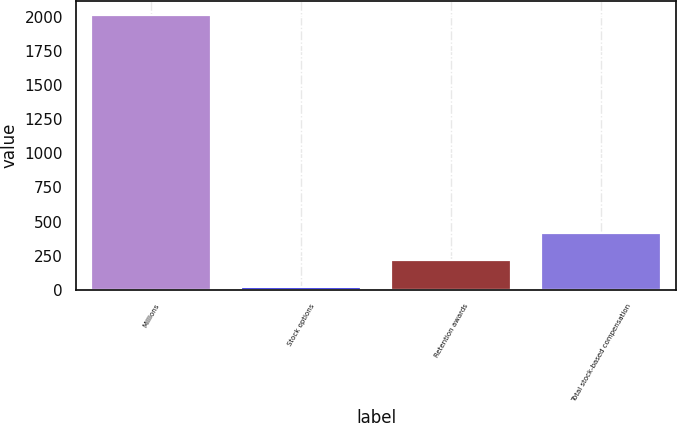<chart> <loc_0><loc_0><loc_500><loc_500><bar_chart><fcel>Millions<fcel>Stock options<fcel>Retention awards<fcel>Total stock-based compensation<nl><fcel>2013<fcel>19<fcel>218.4<fcel>417.8<nl></chart> 